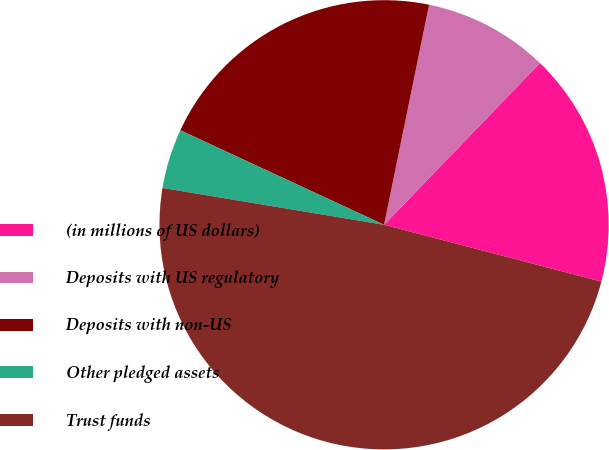Convert chart. <chart><loc_0><loc_0><loc_500><loc_500><pie_chart><fcel>(in millions of US dollars)<fcel>Deposits with US regulatory<fcel>Deposits with non-US<fcel>Other pledged assets<fcel>Trust funds<nl><fcel>16.87%<fcel>8.99%<fcel>21.3%<fcel>4.29%<fcel>48.55%<nl></chart> 